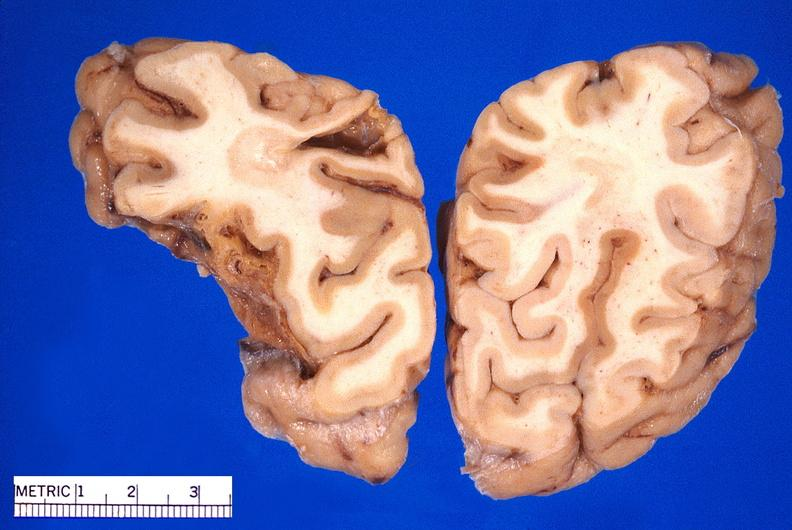s nervous present?
Answer the question using a single word or phrase. Yes 